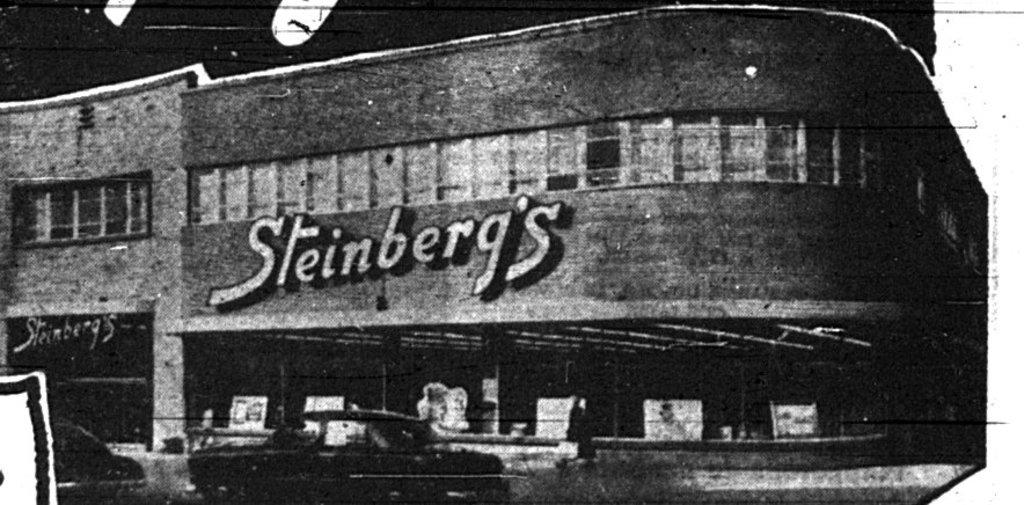What is featured on the poster in the image? The poster depicts a building with windows. Can you describe the building on the poster? The building on the poster has windows. What else can be seen in the image besides the poster? There is a car present on the road in the image. Where is the scarecrow located in the image? There is no scarecrow present in the image. What action is the building on the poster performing in the image? The building on the poster is not performing any action, as it is a static image. 